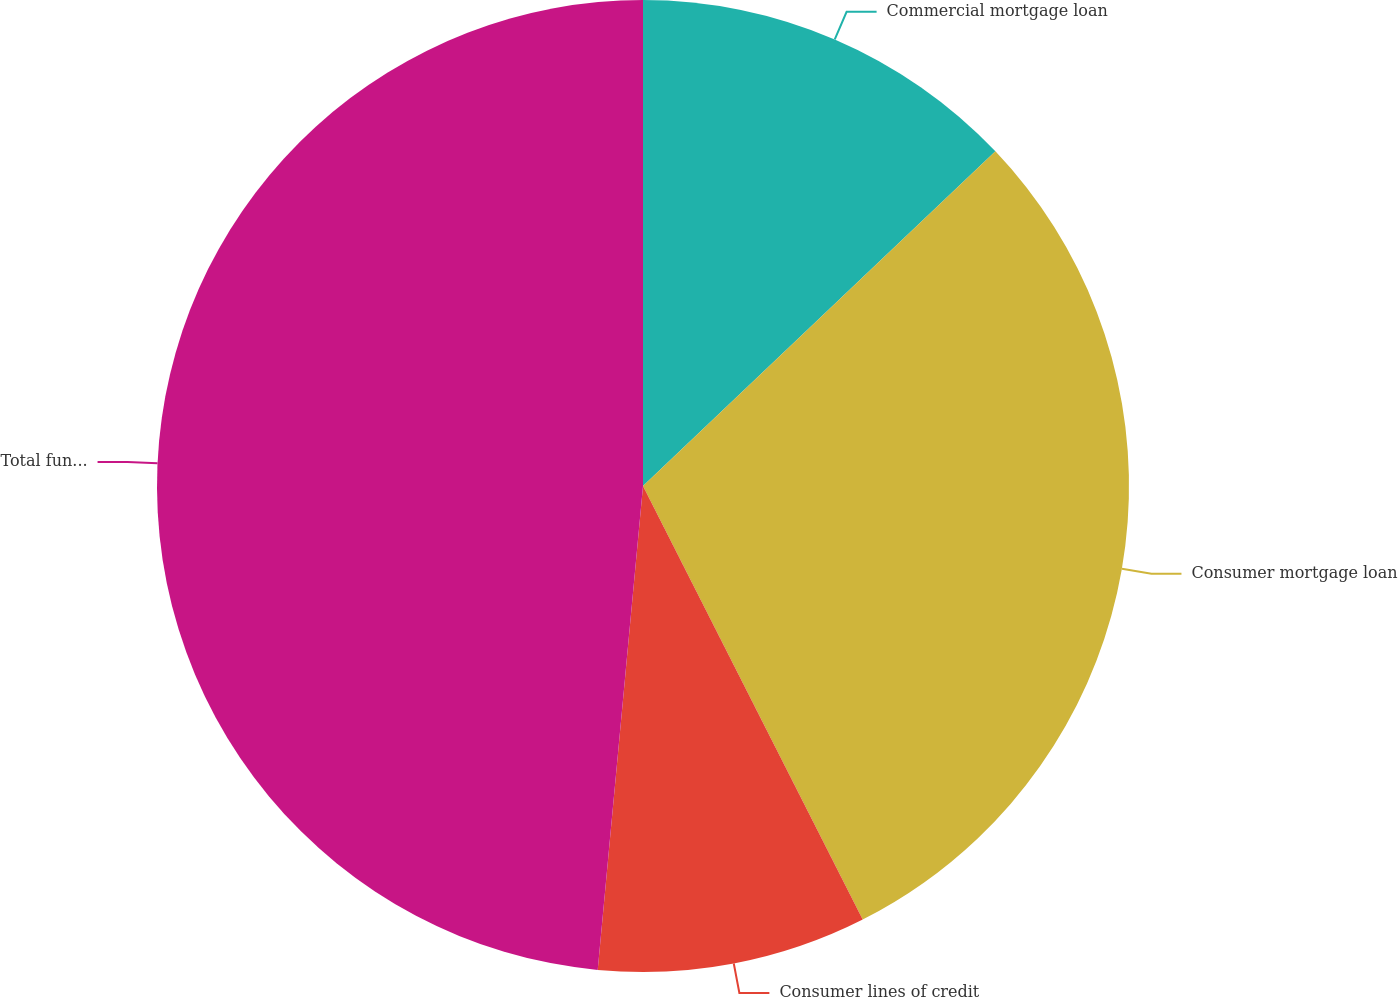Convert chart. <chart><loc_0><loc_0><loc_500><loc_500><pie_chart><fcel>Commercial mortgage loan<fcel>Consumer mortgage loan<fcel>Consumer lines of credit<fcel>Total funding commitments<nl><fcel>12.91%<fcel>29.62%<fcel>8.95%<fcel>48.51%<nl></chart> 